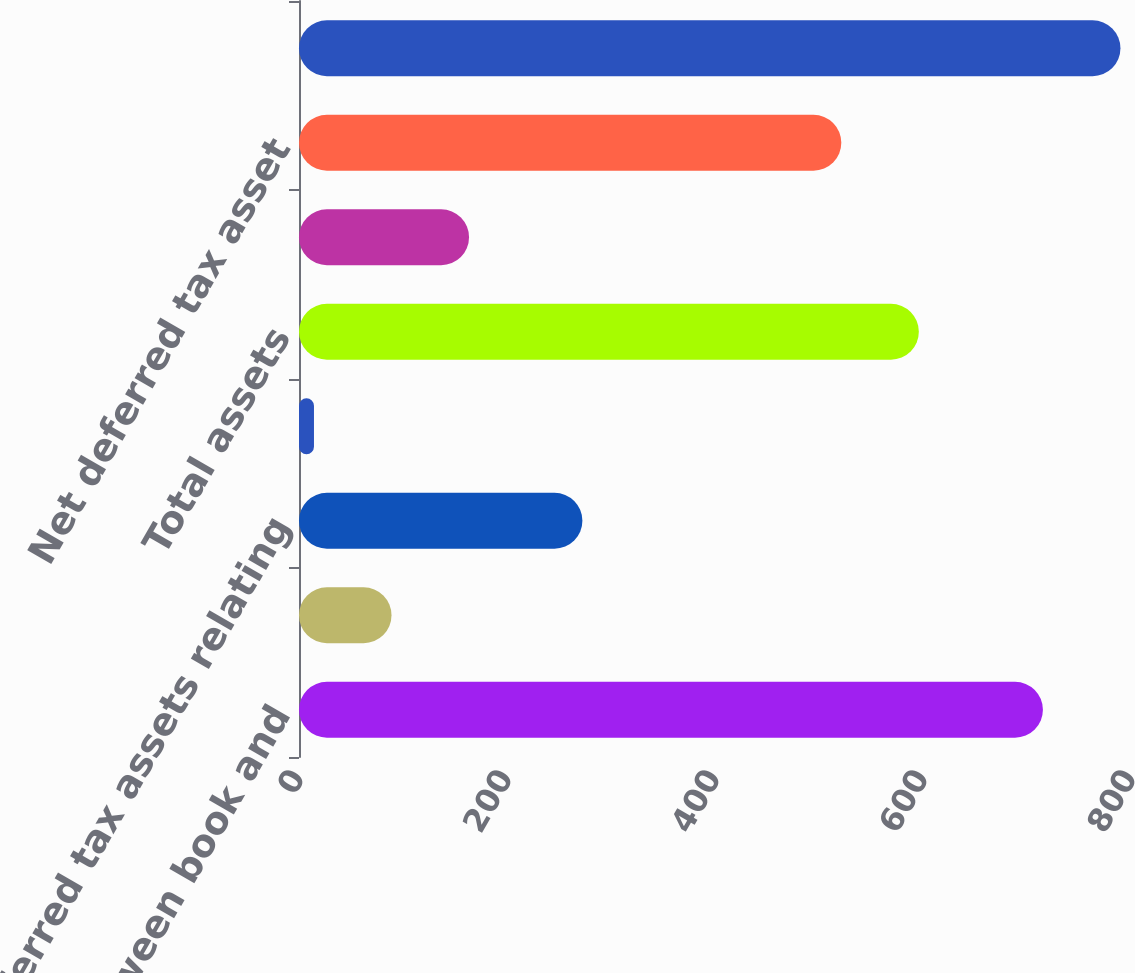<chart> <loc_0><loc_0><loc_500><loc_500><bar_chart><fcel>Differences between book and<fcel>Difference between book and<fcel>Deferred tax assets relating<fcel>Other<fcel>Total assets<fcel>Valuation allowance<fcel>Net deferred tax asset<fcel>Net deferred tax liabilities<nl><fcel>715.3<fcel>88.95<fcel>272.5<fcel>14.4<fcel>596<fcel>163.5<fcel>521.45<fcel>789.85<nl></chart> 